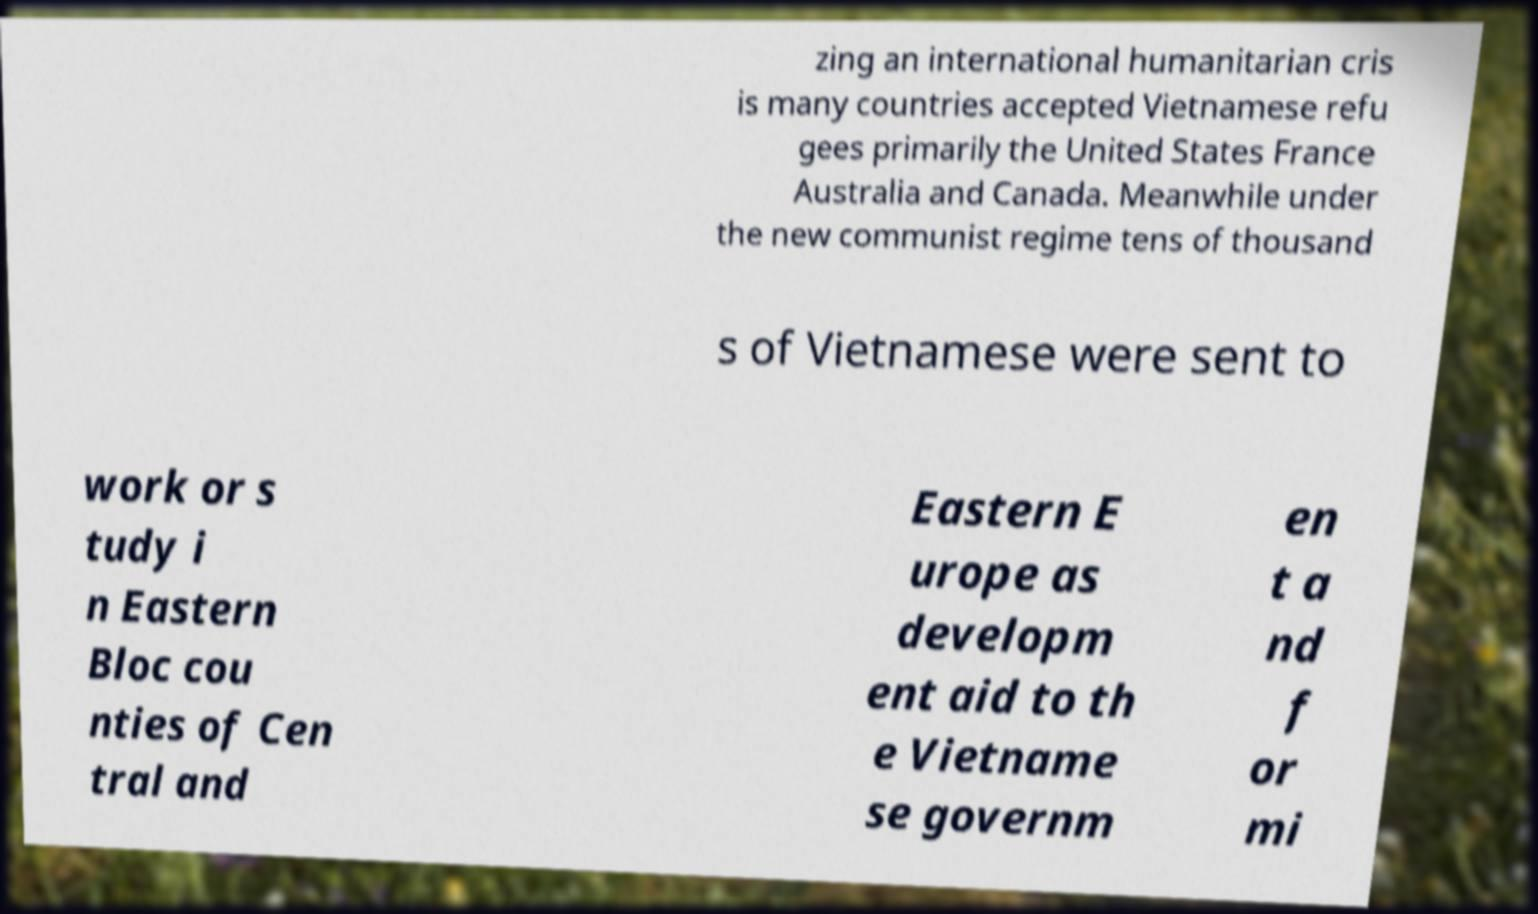There's text embedded in this image that I need extracted. Can you transcribe it verbatim? zing an international humanitarian cris is many countries accepted Vietnamese refu gees primarily the United States France Australia and Canada. Meanwhile under the new communist regime tens of thousand s of Vietnamese were sent to work or s tudy i n Eastern Bloc cou nties of Cen tral and Eastern E urope as developm ent aid to th e Vietname se governm en t a nd f or mi 